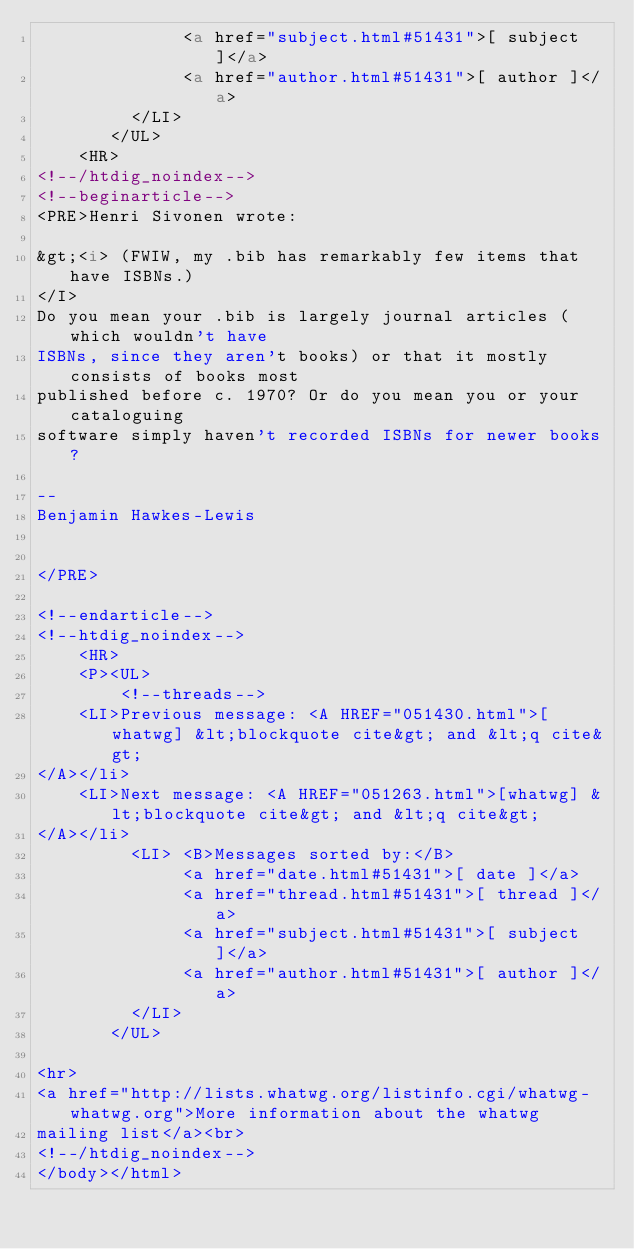Convert code to text. <code><loc_0><loc_0><loc_500><loc_500><_HTML_>              <a href="subject.html#51431">[ subject ]</a>
              <a href="author.html#51431">[ author ]</a>
         </LI>
       </UL>
    <HR>  
<!--/htdig_noindex-->
<!--beginarticle-->
<PRE>Henri Sivonen wrote:

&gt;<i> (FWIW, my .bib has remarkably few items that have ISBNs.)
</I>
Do you mean your .bib is largely journal articles (which wouldn't have
ISBNs, since they aren't books) or that it mostly consists of books most
published before c. 1970? Or do you mean you or your cataloguing
software simply haven't recorded ISBNs for newer books?

--
Benjamin Hawkes-Lewis


</PRE>

<!--endarticle-->
<!--htdig_noindex-->
    <HR>
    <P><UL>
        <!--threads-->
	<LI>Previous message: <A HREF="051430.html">[whatwg] &lt;blockquote cite&gt; and &lt;q cite&gt;
</A></li>
	<LI>Next message: <A HREF="051263.html">[whatwg] &lt;blockquote cite&gt; and &lt;q cite&gt;
</A></li>
         <LI> <B>Messages sorted by:</B> 
              <a href="date.html#51431">[ date ]</a>
              <a href="thread.html#51431">[ thread ]</a>
              <a href="subject.html#51431">[ subject ]</a>
              <a href="author.html#51431">[ author ]</a>
         </LI>
       </UL>

<hr>
<a href="http://lists.whatwg.org/listinfo.cgi/whatwg-whatwg.org">More information about the whatwg
mailing list</a><br>
<!--/htdig_noindex-->
</body></html>
</code> 